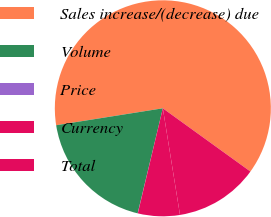<chart> <loc_0><loc_0><loc_500><loc_500><pie_chart><fcel>Sales increase/(decrease) due<fcel>Volume<fcel>Price<fcel>Currency<fcel>Total<nl><fcel>62.45%<fcel>18.75%<fcel>0.02%<fcel>6.26%<fcel>12.51%<nl></chart> 